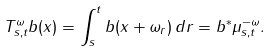<formula> <loc_0><loc_0><loc_500><loc_500>T ^ { \omega } _ { s , t } b ( x ) = \int _ { s } ^ { t } b ( x + \omega _ { r } ) \, d r = b ^ { * } \mu _ { s , t } ^ { - \omega } .</formula> 